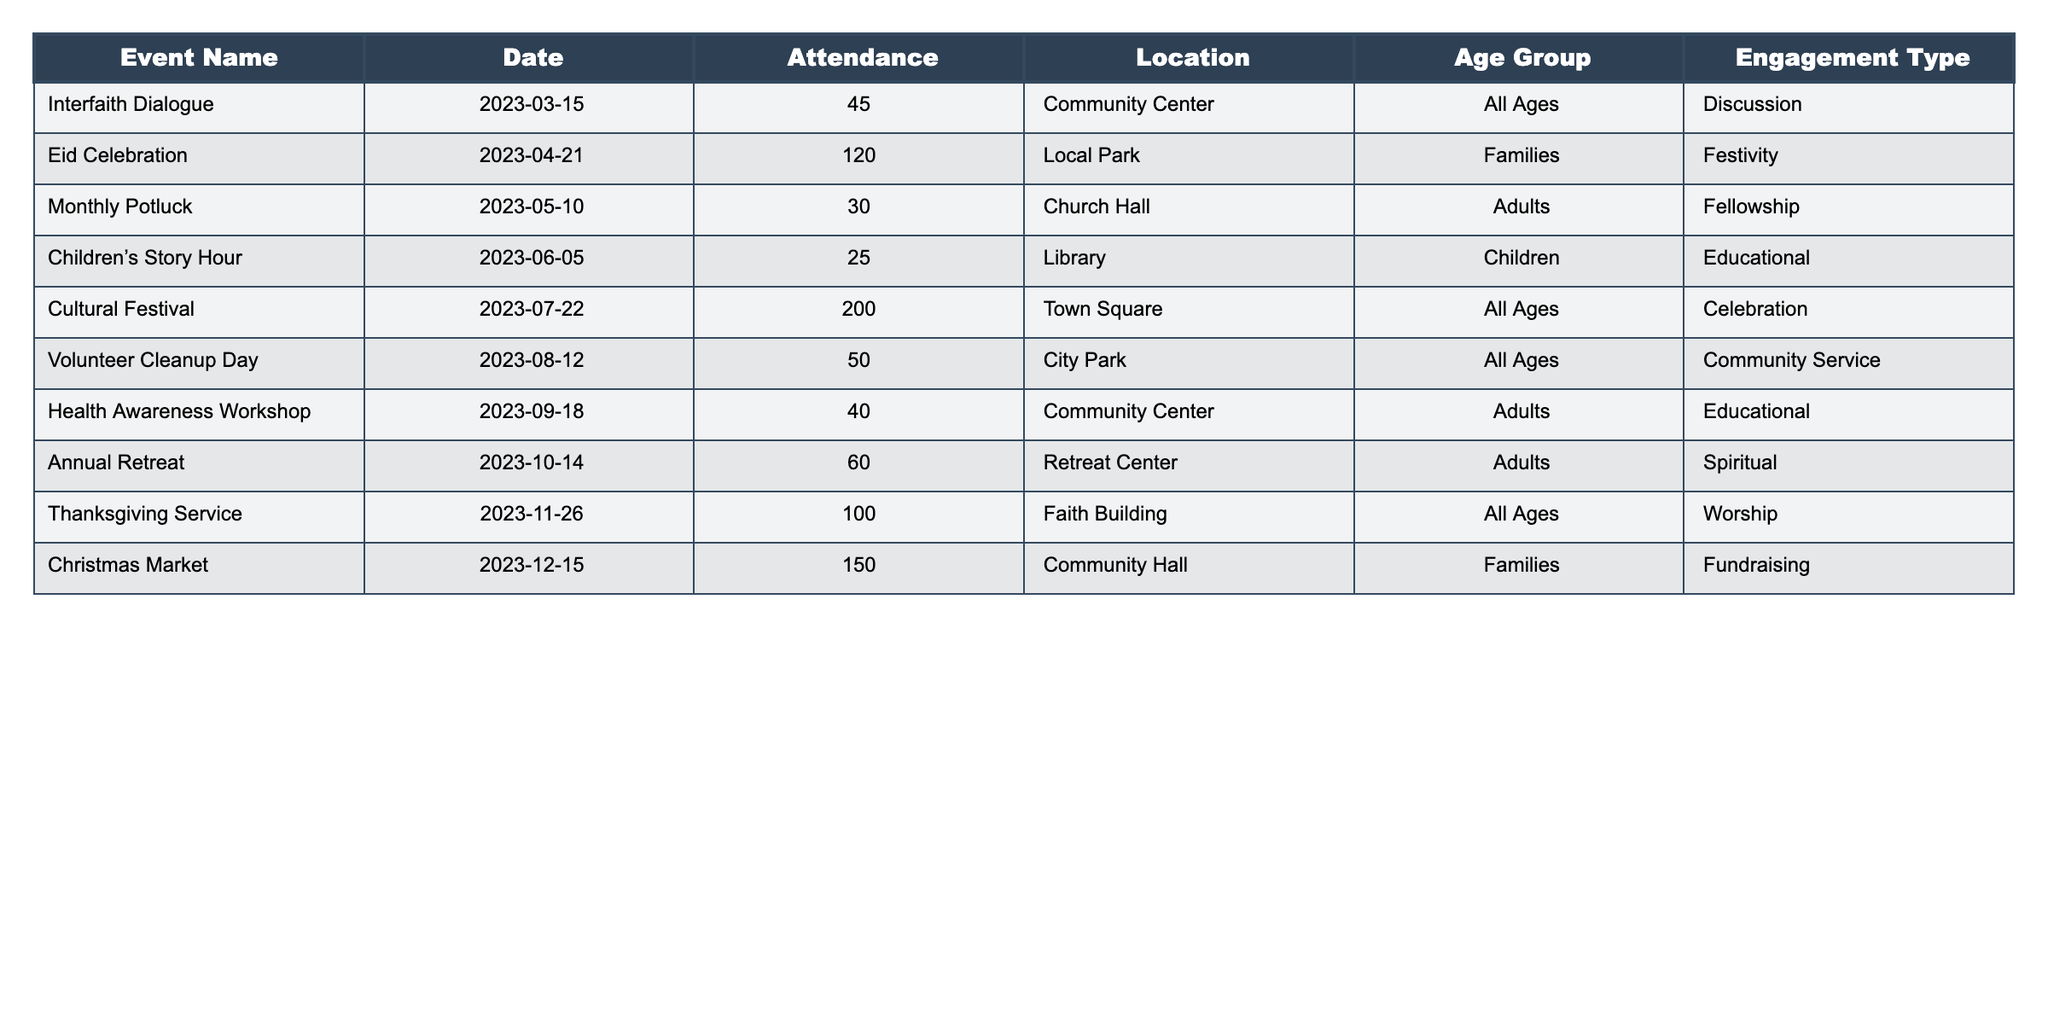What was the highest attendance recorded for a single event? By reviewing the attendance figures for all events listed, the highest attendance is 200 for the Cultural Festival.
Answer: 200 Which event focused on educational activities for children? The event that specifically targeted children's educational engagement is the Children's Story Hour, which had an attendance of 25.
Answer: Children's Story Hour How many events were held in the summer months (June, July, and August)? Looking at the table, there are three events held in those months: Children's Story Hour in June, Cultural Festival in July, and Volunteer Cleanup Day in August.
Answer: 3 What is the total attendance for events categorized under "Worship" and "Spiritual"? From the table, the Thanksgiving Service (100) and the Annual Retreat (60) are categorized under those types. Adding those together gives 100 + 60 = 160.
Answer: 160 Did any events occur in a library or community center? Yes, the Children's Story Hour is held in a library and the Interfaith Dialogue and Health Awareness Workshop are at a community center.
Answer: Yes What is the average attendance for adult-focused events? The adult-focused events include the Monthly Potluck (30), Health Awareness Workshop (40), and Annual Retreat (60). Adding these gives 30 + 40 + 60 = 130, and dividing by 3 results in 130 / 3 ≈ 43.33.
Answer: 43.33 Which age group had the highest attendance in community events? The event with the highest attendance, the Cultural Festival, includes all ages, with a count of 200. Thus, the age group with the highest attendance is "All Ages."
Answer: All Ages How many total participants attended events focused on festivity and celebration? The Eid Celebration (120) and Cultural Festival (200) are both categorized under festivity and celebration, leading to a total of 120 + 200 = 320 participants.
Answer: 320 What percentage of the total attendance came from events held in a park? Events in parks are the Eid Celebration (120) and Volunteer Cleanup Day (50), totaling 120 + 50 = 170. The overall attendance across all events is 45 + 120 + 30 + 25 + 200 + 50 + 40 + 60 + 100 + 150 = 870. The percentage is (170 / 870) * 100 ≈ 19.54%.
Answer: Approximately 19.54% What is the difference in attendance between the event with the lowest and highest attendance? The Children's Story Hour had the lowest attendance with 25 and the Cultural Festival had the highest with 200. The difference is 200 - 25 = 175.
Answer: 175 